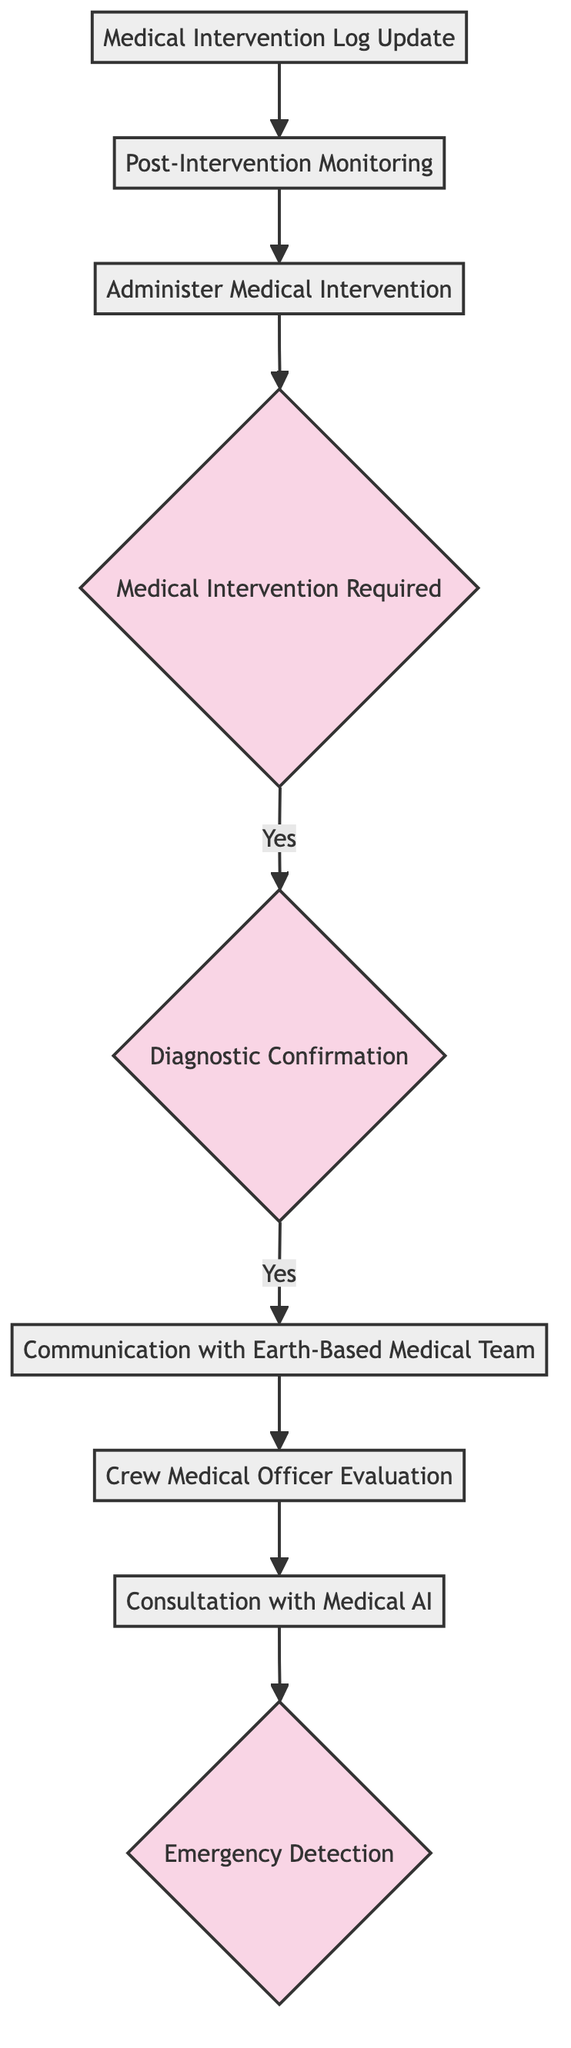What is the first step in the diagram? The first step is "Emergency Detection", which is the initial point to identify if there is a real-time health emergency detected.
Answer: Emergency Detection How many process nodes are present in the diagram? The diagram has 6 process nodes: Consultation with Medical AI, Crew Medical Officer Evaluation, Communication with Earth-Based Medical Team, Administer Medical Intervention, Post-Intervention Monitoring, and Medical Intervention Log Update.
Answer: 6 What happens after "Crew Medical Officer Evaluation"? After "Crew Medical Officer Evaluation," the next step is "Communication with Earth-Based Medical Team," where communication is established for further input.
Answer: Communication with Earth-Based Medical Team What decision follows "Diagnostic Confirmation"? The decision that follows "Diagnostic Confirmation" is "Medical Intervention Required," determining if intervention is needed based on the diagnosis confirmation.
Answer: Medical Intervention Required What is the outcome when "Medical Intervention Required" is answered affirmatively? When "Medical Intervention Required" is answered with a "yes," the process moves to "Administer Medical Intervention" where the medical intervention is executed.
Answer: Administer Medical Intervention What type of diagram is represented here? The diagram is a programming flowchart that illustrates the decision-making process for administering medical interventions during space missions.
Answer: Programming flowchart 